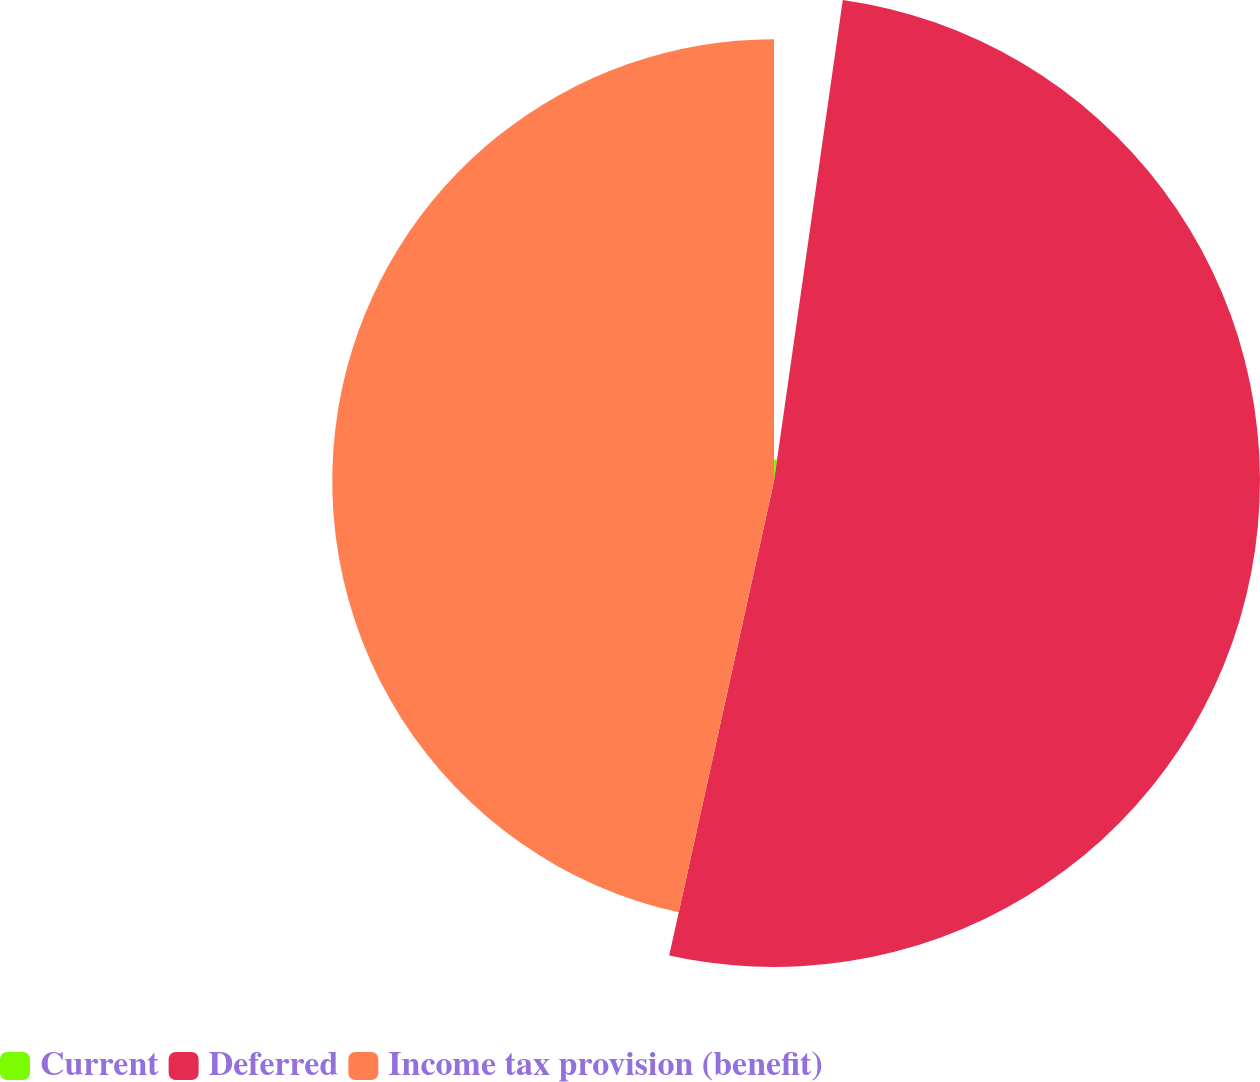<chart> <loc_0><loc_0><loc_500><loc_500><pie_chart><fcel>Current<fcel>Deferred<fcel>Income tax provision (benefit)<nl><fcel>2.26%<fcel>51.2%<fcel>46.54%<nl></chart> 